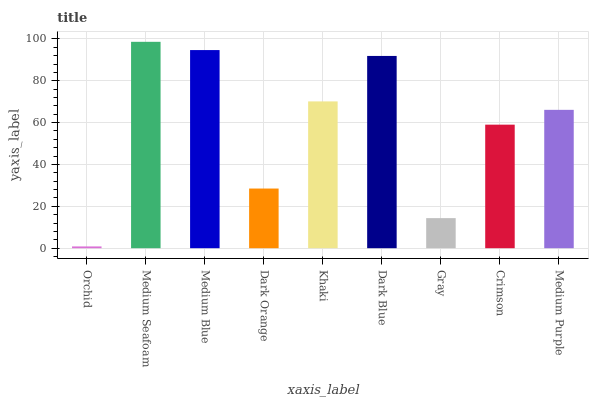Is Orchid the minimum?
Answer yes or no. Yes. Is Medium Seafoam the maximum?
Answer yes or no. Yes. Is Medium Blue the minimum?
Answer yes or no. No. Is Medium Blue the maximum?
Answer yes or no. No. Is Medium Seafoam greater than Medium Blue?
Answer yes or no. Yes. Is Medium Blue less than Medium Seafoam?
Answer yes or no. Yes. Is Medium Blue greater than Medium Seafoam?
Answer yes or no. No. Is Medium Seafoam less than Medium Blue?
Answer yes or no. No. Is Medium Purple the high median?
Answer yes or no. Yes. Is Medium Purple the low median?
Answer yes or no. Yes. Is Medium Seafoam the high median?
Answer yes or no. No. Is Dark Blue the low median?
Answer yes or no. No. 